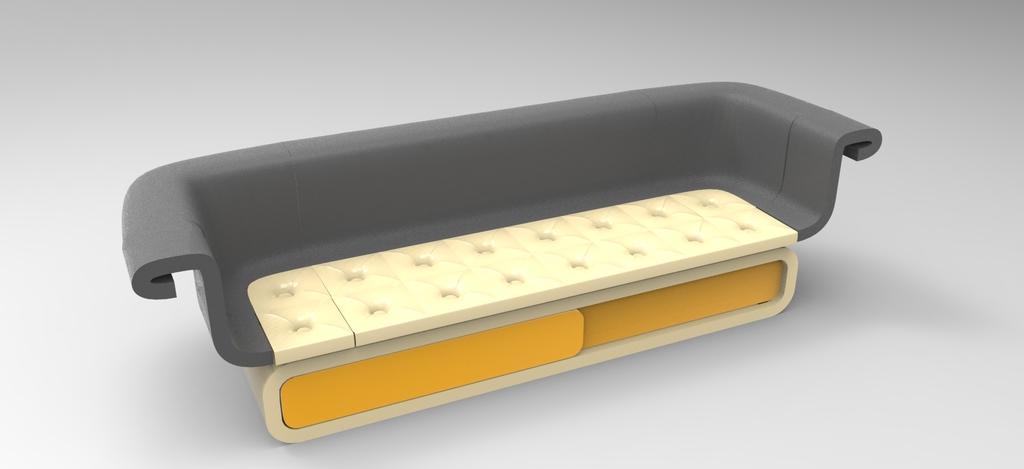Can you describe this image briefly? In this picture I can observe sofa in the middle of the picture. This is a graphical image. The background is in grey color. 